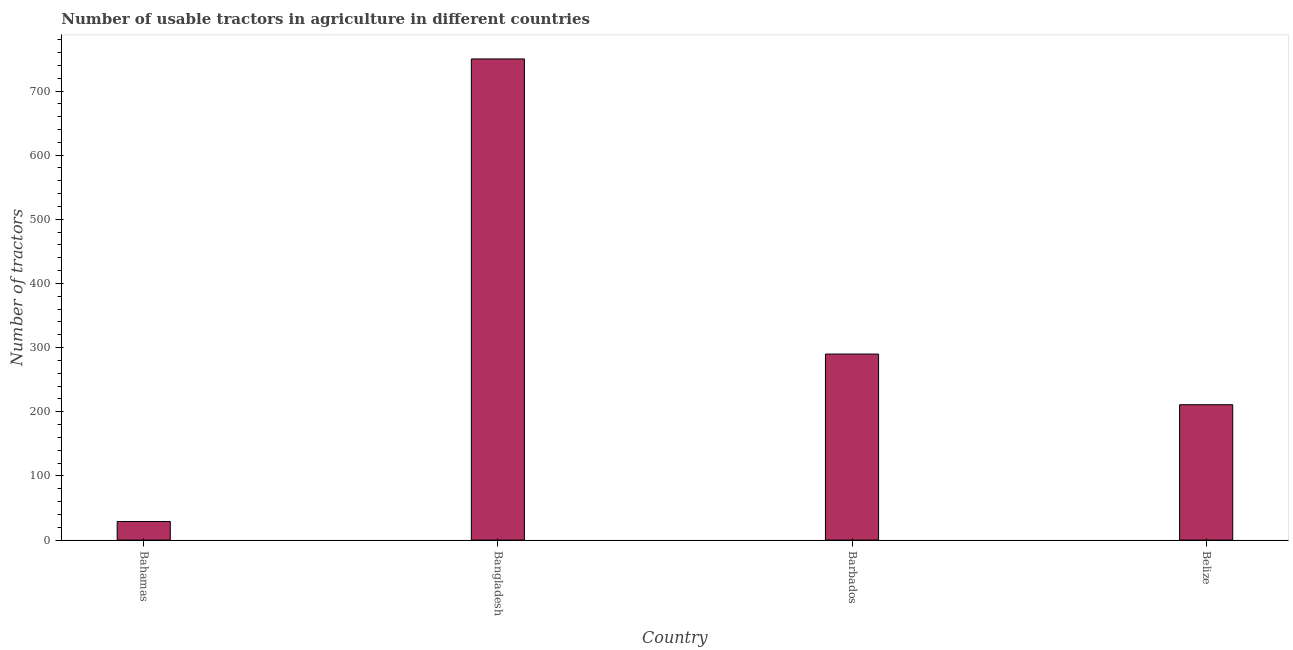Does the graph contain grids?
Your answer should be very brief. No. What is the title of the graph?
Provide a short and direct response. Number of usable tractors in agriculture in different countries. What is the label or title of the X-axis?
Offer a very short reply. Country. What is the label or title of the Y-axis?
Give a very brief answer. Number of tractors. What is the number of tractors in Belize?
Your answer should be very brief. 211. Across all countries, what is the maximum number of tractors?
Offer a terse response. 750. In which country was the number of tractors maximum?
Give a very brief answer. Bangladesh. In which country was the number of tractors minimum?
Keep it short and to the point. Bahamas. What is the sum of the number of tractors?
Your answer should be very brief. 1280. What is the difference between the number of tractors in Bahamas and Bangladesh?
Offer a terse response. -721. What is the average number of tractors per country?
Give a very brief answer. 320. What is the median number of tractors?
Your response must be concise. 250.5. What is the ratio of the number of tractors in Bahamas to that in Barbados?
Your response must be concise. 0.1. Is the number of tractors in Bahamas less than that in Belize?
Ensure brevity in your answer.  Yes. Is the difference between the number of tractors in Bahamas and Belize greater than the difference between any two countries?
Keep it short and to the point. No. What is the difference between the highest and the second highest number of tractors?
Ensure brevity in your answer.  460. Is the sum of the number of tractors in Bangladesh and Barbados greater than the maximum number of tractors across all countries?
Your answer should be very brief. Yes. What is the difference between the highest and the lowest number of tractors?
Ensure brevity in your answer.  721. In how many countries, is the number of tractors greater than the average number of tractors taken over all countries?
Make the answer very short. 1. Are all the bars in the graph horizontal?
Give a very brief answer. No. What is the Number of tractors in Bahamas?
Your response must be concise. 29. What is the Number of tractors in Bangladesh?
Provide a succinct answer. 750. What is the Number of tractors of Barbados?
Your answer should be compact. 290. What is the Number of tractors in Belize?
Give a very brief answer. 211. What is the difference between the Number of tractors in Bahamas and Bangladesh?
Provide a succinct answer. -721. What is the difference between the Number of tractors in Bahamas and Barbados?
Offer a terse response. -261. What is the difference between the Number of tractors in Bahamas and Belize?
Provide a succinct answer. -182. What is the difference between the Number of tractors in Bangladesh and Barbados?
Provide a short and direct response. 460. What is the difference between the Number of tractors in Bangladesh and Belize?
Provide a short and direct response. 539. What is the difference between the Number of tractors in Barbados and Belize?
Ensure brevity in your answer.  79. What is the ratio of the Number of tractors in Bahamas to that in Bangladesh?
Offer a terse response. 0.04. What is the ratio of the Number of tractors in Bahamas to that in Belize?
Ensure brevity in your answer.  0.14. What is the ratio of the Number of tractors in Bangladesh to that in Barbados?
Provide a succinct answer. 2.59. What is the ratio of the Number of tractors in Bangladesh to that in Belize?
Your response must be concise. 3.56. What is the ratio of the Number of tractors in Barbados to that in Belize?
Make the answer very short. 1.37. 